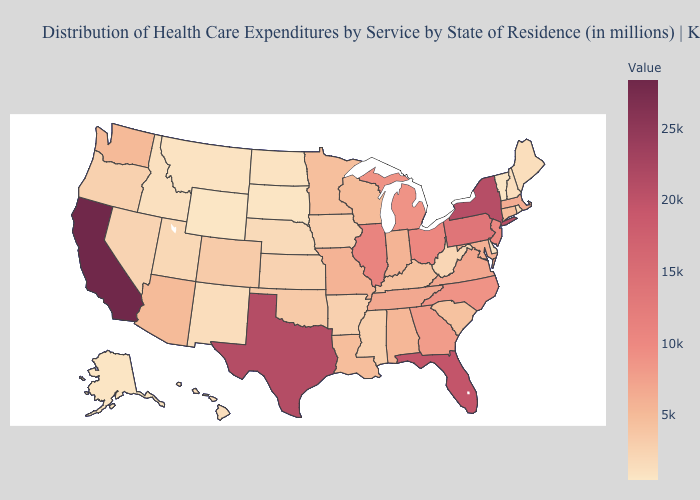Does Kansas have a lower value than Michigan?
Short answer required. Yes. Among the states that border Texas , does New Mexico have the lowest value?
Concise answer only. Yes. Does North Dakota have the lowest value in the MidWest?
Give a very brief answer. No. Among the states that border Utah , which have the lowest value?
Be succinct. Wyoming. 